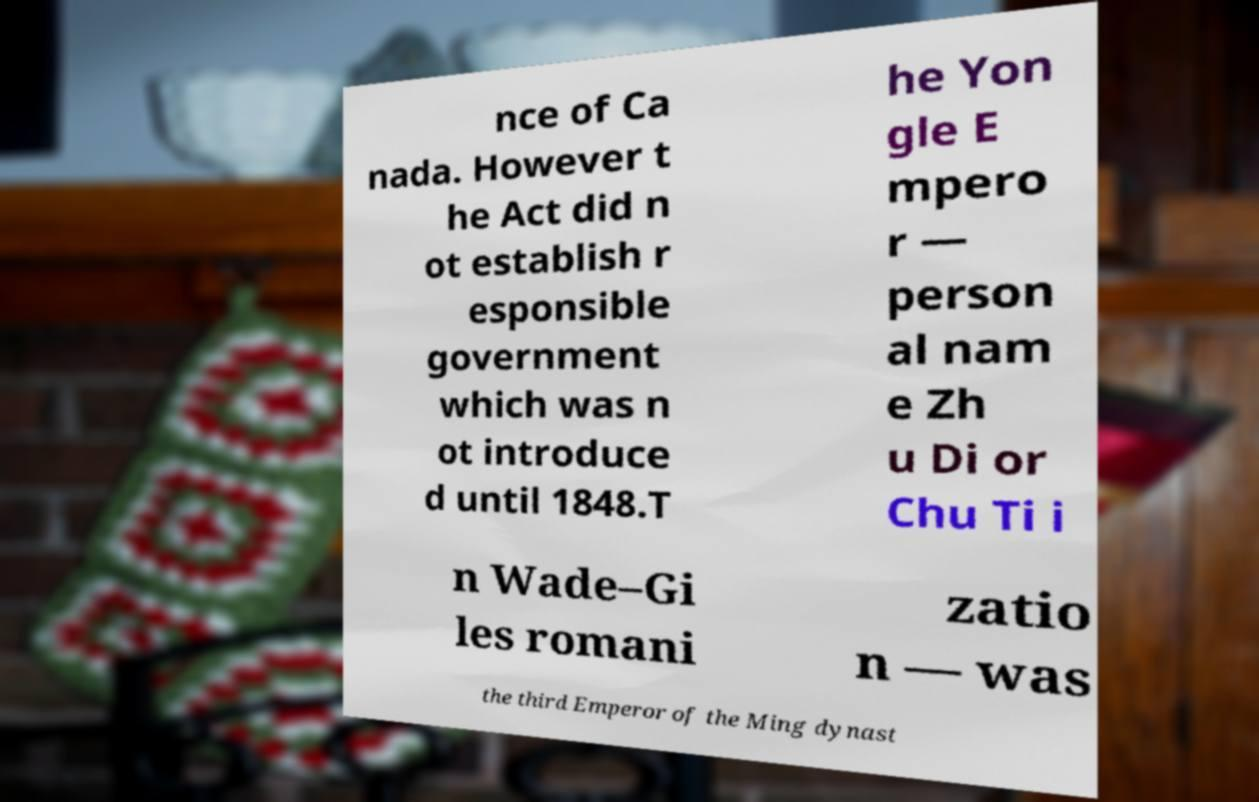Can you read and provide the text displayed in the image?This photo seems to have some interesting text. Can you extract and type it out for me? nce of Ca nada. However t he Act did n ot establish r esponsible government which was n ot introduce d until 1848.T he Yon gle E mpero r — person al nam e Zh u Di or Chu Ti i n Wade–Gi les romani zatio n — was the third Emperor of the Ming dynast 